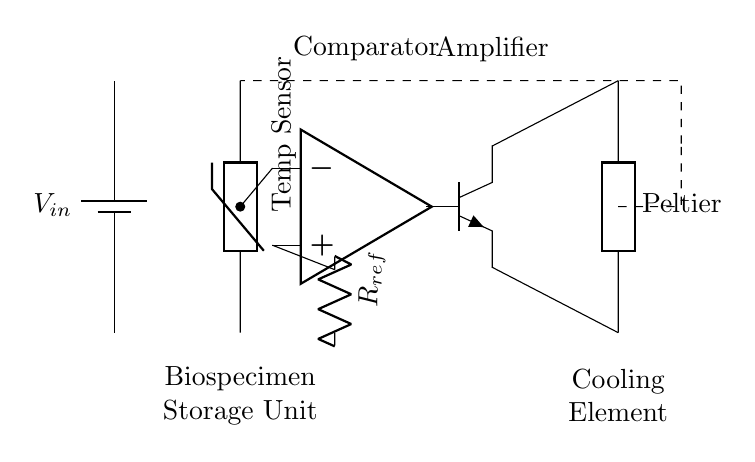What component is used as a temperature sensor? The circuit uses a thermistor as a temperature sensor, which is indicated in the diagram labeled as "Temp Sensor."
Answer: thermistor What is the function of the comparator in this circuit? The comparator compares the voltage from the thermistor with a reference voltage to determine if the temperature is above or below a set point, which helps control the cooling mechanism.
Answer: control temperature Which component acts as the cooling element in this circuit? The cooling element is a Peltier device, which is shown in the diagram labeled as "Peltier." It is responsible for cooling the biospecimen storage unit when activated.
Answer: Peltier What type of transistor is used to control the Peltier device? The circuit uses an NPN transistor, indicated in the diagram with the label npn, which is used to switch the Peltier on and off based on the output from the comparator.
Answer: NPN How is feedback provided to the temperature sensor? Feedback is provided by a dashed line connecting the cooling element output back to the temperature sensor input, allowing the system to maintain the desired temperature by adjusting the Peltier's operation based on real-time temperature readings.
Answer: feedback loop What is the purpose of the resistor labeled R_ref? The resistor labeled R_ref is used to provide a reference voltage for the comparator to compare the thermistor's voltage output against, playing a crucial role in the temperature regulation process.
Answer: reference voltage 